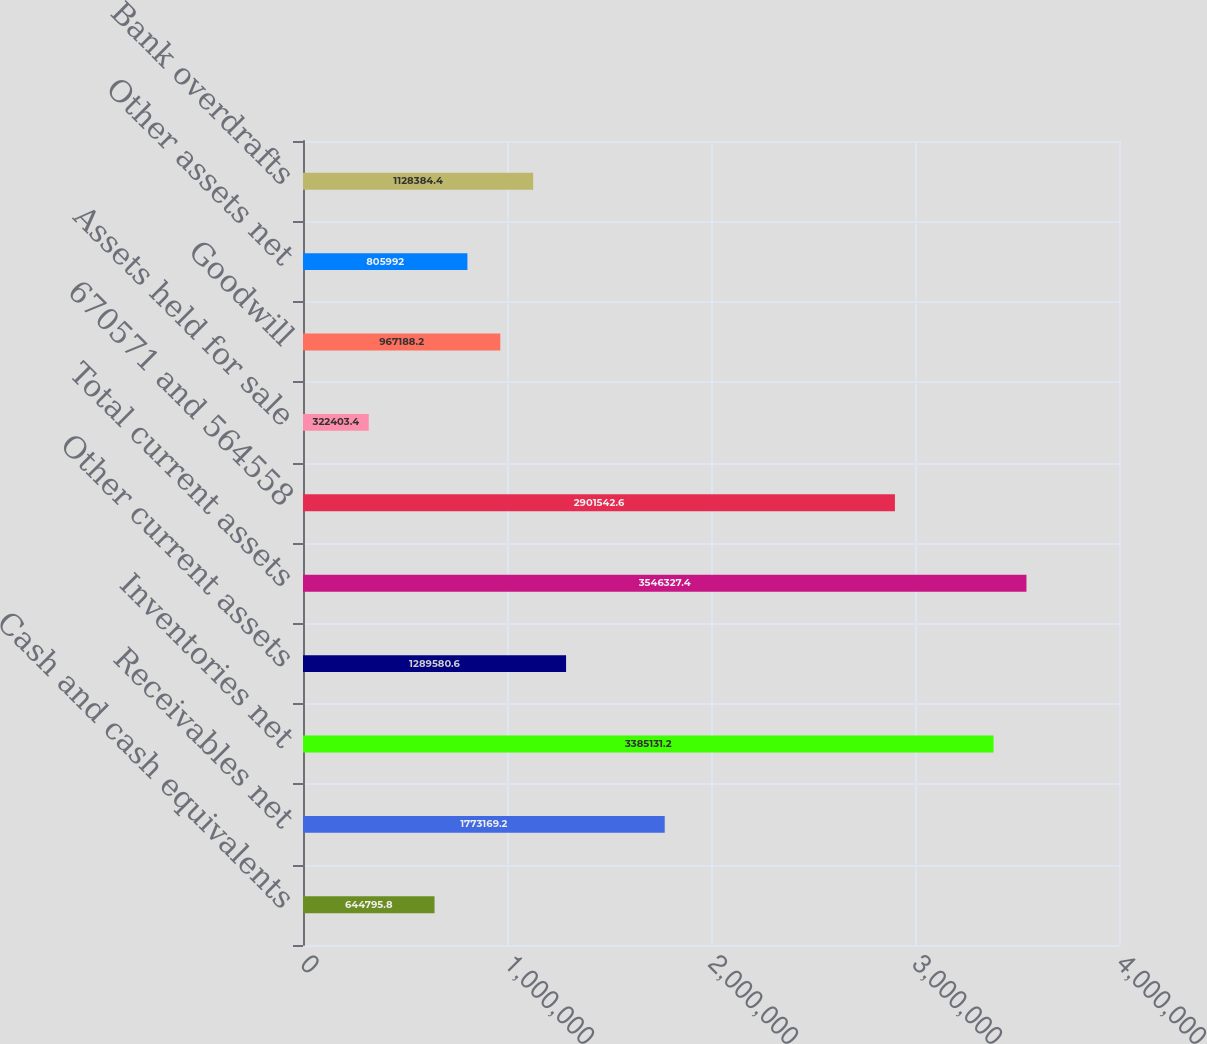<chart> <loc_0><loc_0><loc_500><loc_500><bar_chart><fcel>Cash and cash equivalents<fcel>Receivables net<fcel>Inventories net<fcel>Other current assets<fcel>Total current assets<fcel>670571 and 564558<fcel>Assets held for sale<fcel>Goodwill<fcel>Other assets net<fcel>Bank overdrafts<nl><fcel>644796<fcel>1.77317e+06<fcel>3.38513e+06<fcel>1.28958e+06<fcel>3.54633e+06<fcel>2.90154e+06<fcel>322403<fcel>967188<fcel>805992<fcel>1.12838e+06<nl></chart> 